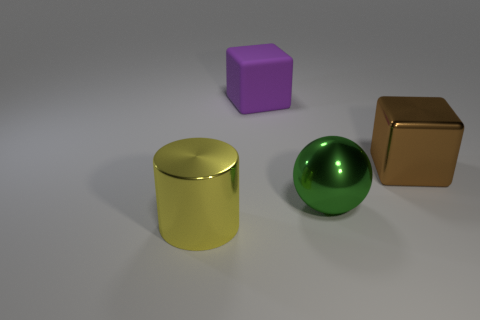Add 3 matte cubes. How many objects exist? 7 Subtract all balls. How many objects are left? 3 Subtract 0 blue blocks. How many objects are left? 4 Subtract all brown blocks. Subtract all blue balls. How many blocks are left? 1 Subtract all big purple balls. Subtract all large green shiny things. How many objects are left? 3 Add 2 big green metal objects. How many big green metal objects are left? 3 Add 1 cyan cylinders. How many cyan cylinders exist? 1 